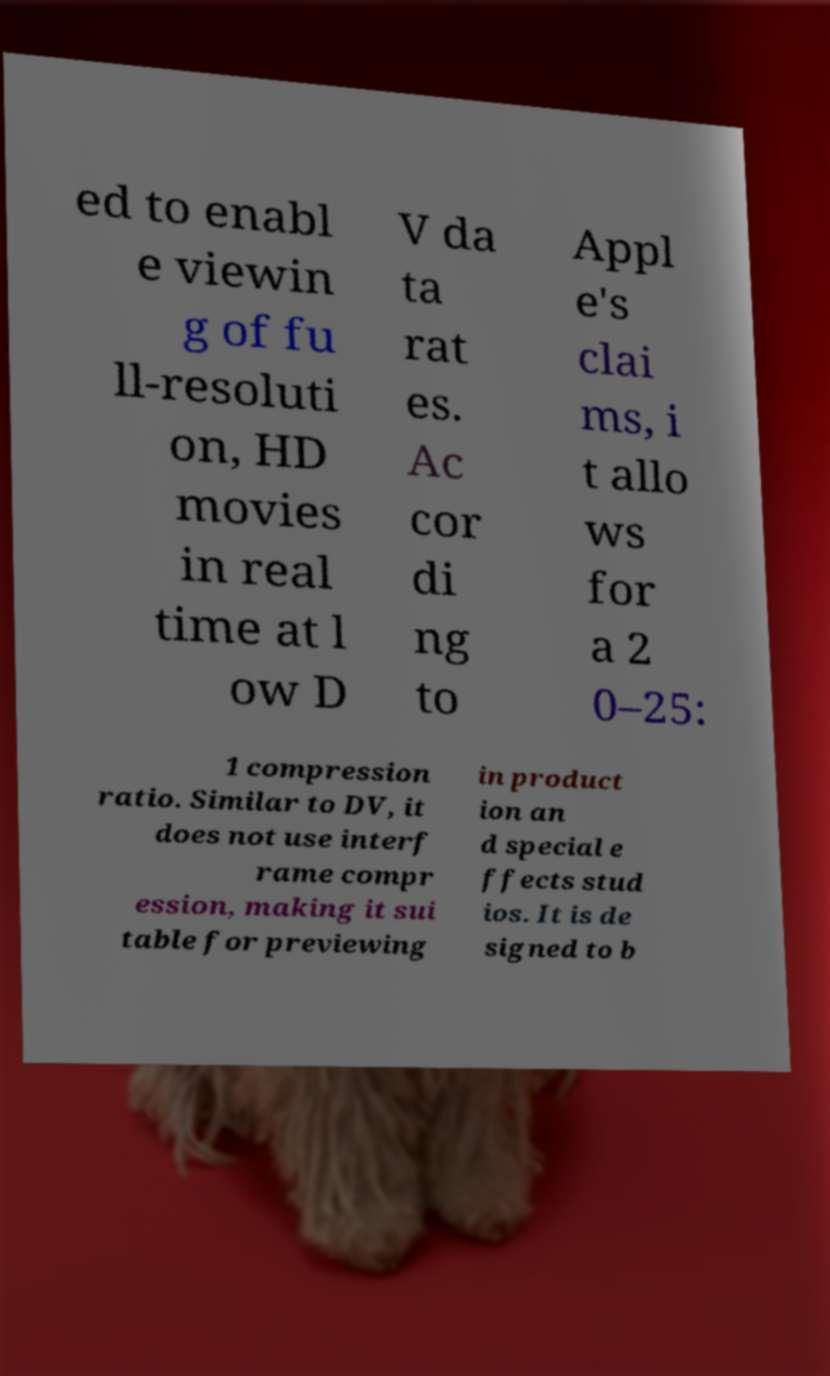Please identify and transcribe the text found in this image. ed to enabl e viewin g of fu ll-resoluti on, HD movies in real time at l ow D V da ta rat es. Ac cor di ng to Appl e's clai ms, i t allo ws for a 2 0–25: 1 compression ratio. Similar to DV, it does not use interf rame compr ession, making it sui table for previewing in product ion an d special e ffects stud ios. It is de signed to b 